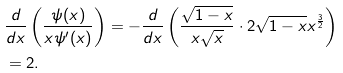Convert formula to latex. <formula><loc_0><loc_0><loc_500><loc_500>& \frac { d } { d x } \left ( \frac { \psi ( x ) } { x \psi ^ { \prime } ( x ) } \right ) = - \frac { d } { d x } \left ( \frac { \sqrt { 1 - x } } { x \sqrt { x } } \cdot 2 \sqrt { 1 - x } x ^ { \frac { 3 } { 2 } } \right ) \\ & = 2 .</formula> 